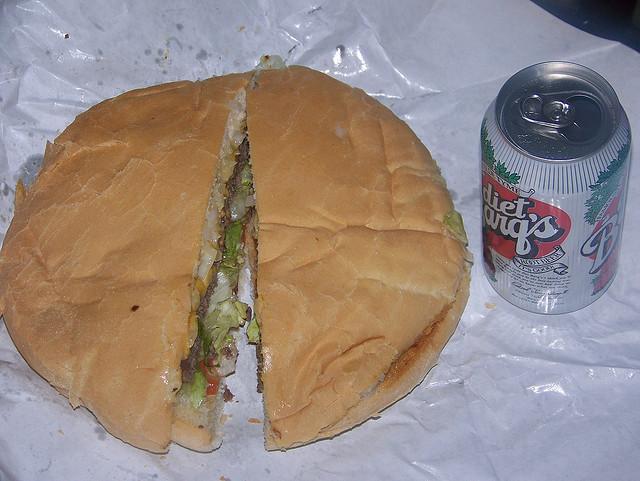How many sandwiches are there?
Give a very brief answer. 1. 